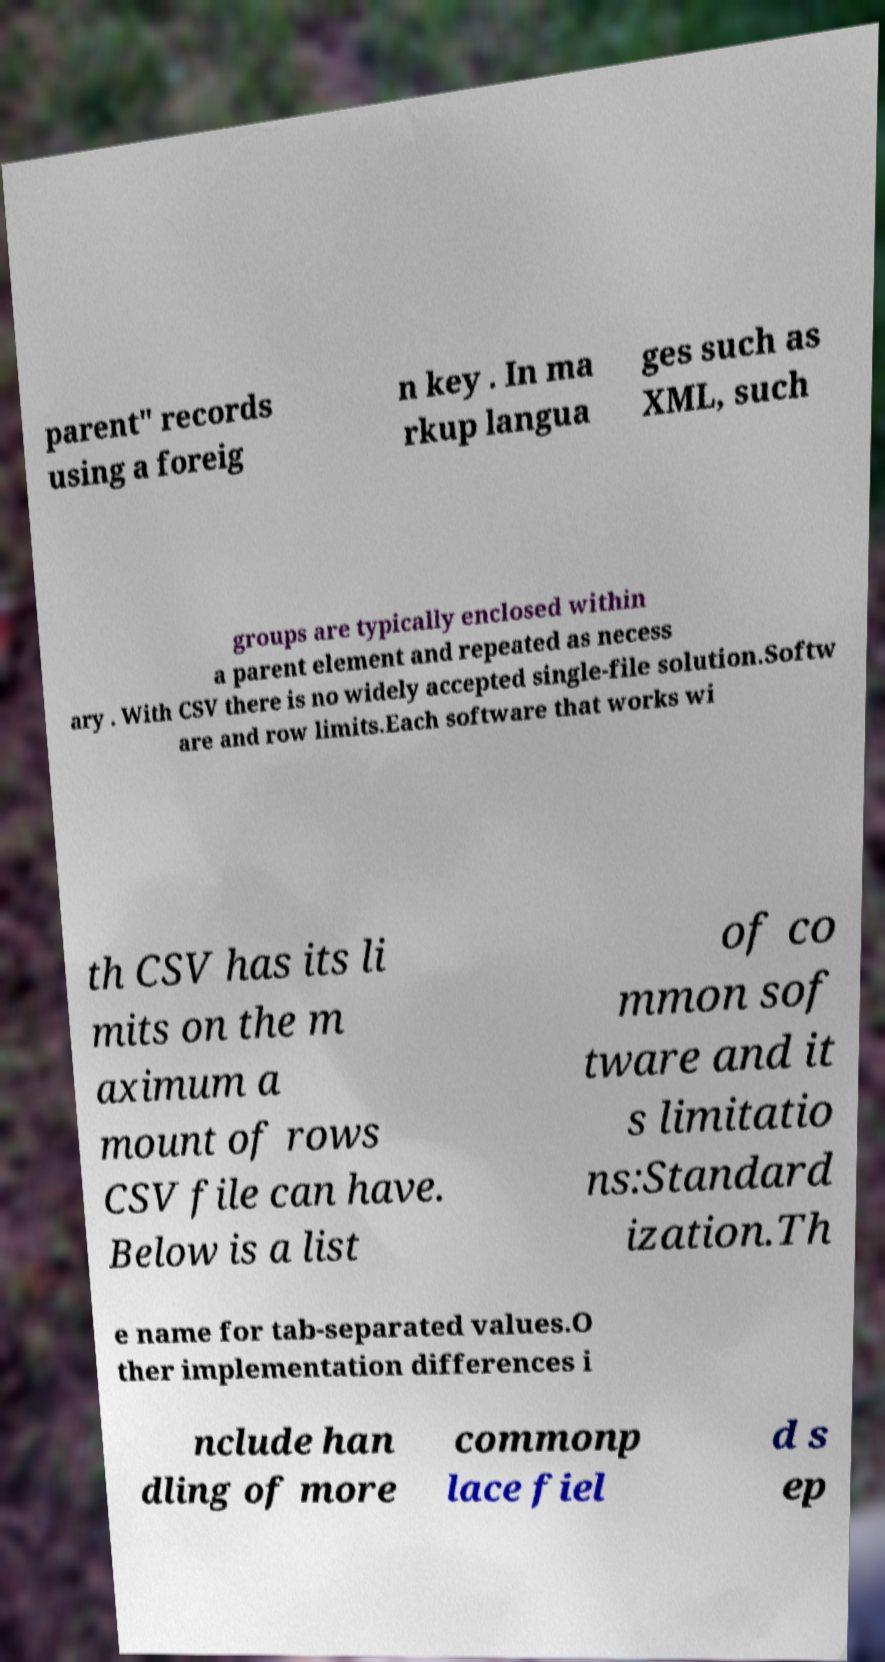Can you read and provide the text displayed in the image?This photo seems to have some interesting text. Can you extract and type it out for me? parent" records using a foreig n key . In ma rkup langua ges such as XML, such groups are typically enclosed within a parent element and repeated as necess ary . With CSV there is no widely accepted single-file solution.Softw are and row limits.Each software that works wi th CSV has its li mits on the m aximum a mount of rows CSV file can have. Below is a list of co mmon sof tware and it s limitatio ns:Standard ization.Th e name for tab-separated values.O ther implementation differences i nclude han dling of more commonp lace fiel d s ep 